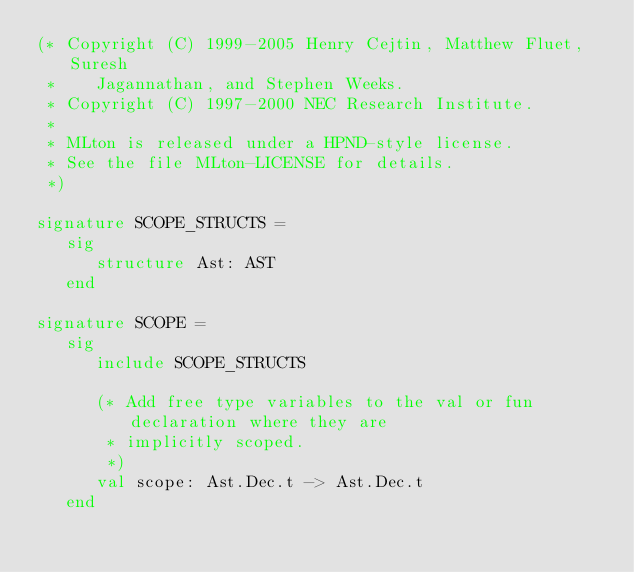Convert code to text. <code><loc_0><loc_0><loc_500><loc_500><_SML_>(* Copyright (C) 1999-2005 Henry Cejtin, Matthew Fluet, Suresh
 *    Jagannathan, and Stephen Weeks.
 * Copyright (C) 1997-2000 NEC Research Institute.
 *
 * MLton is released under a HPND-style license.
 * See the file MLton-LICENSE for details.
 *)

signature SCOPE_STRUCTS =
   sig
      structure Ast: AST
   end

signature SCOPE =
   sig
      include SCOPE_STRUCTS

      (* Add free type variables to the val or fun declaration where they are
       * implicitly scoped.
       *)
      val scope: Ast.Dec.t -> Ast.Dec.t
   end
</code> 